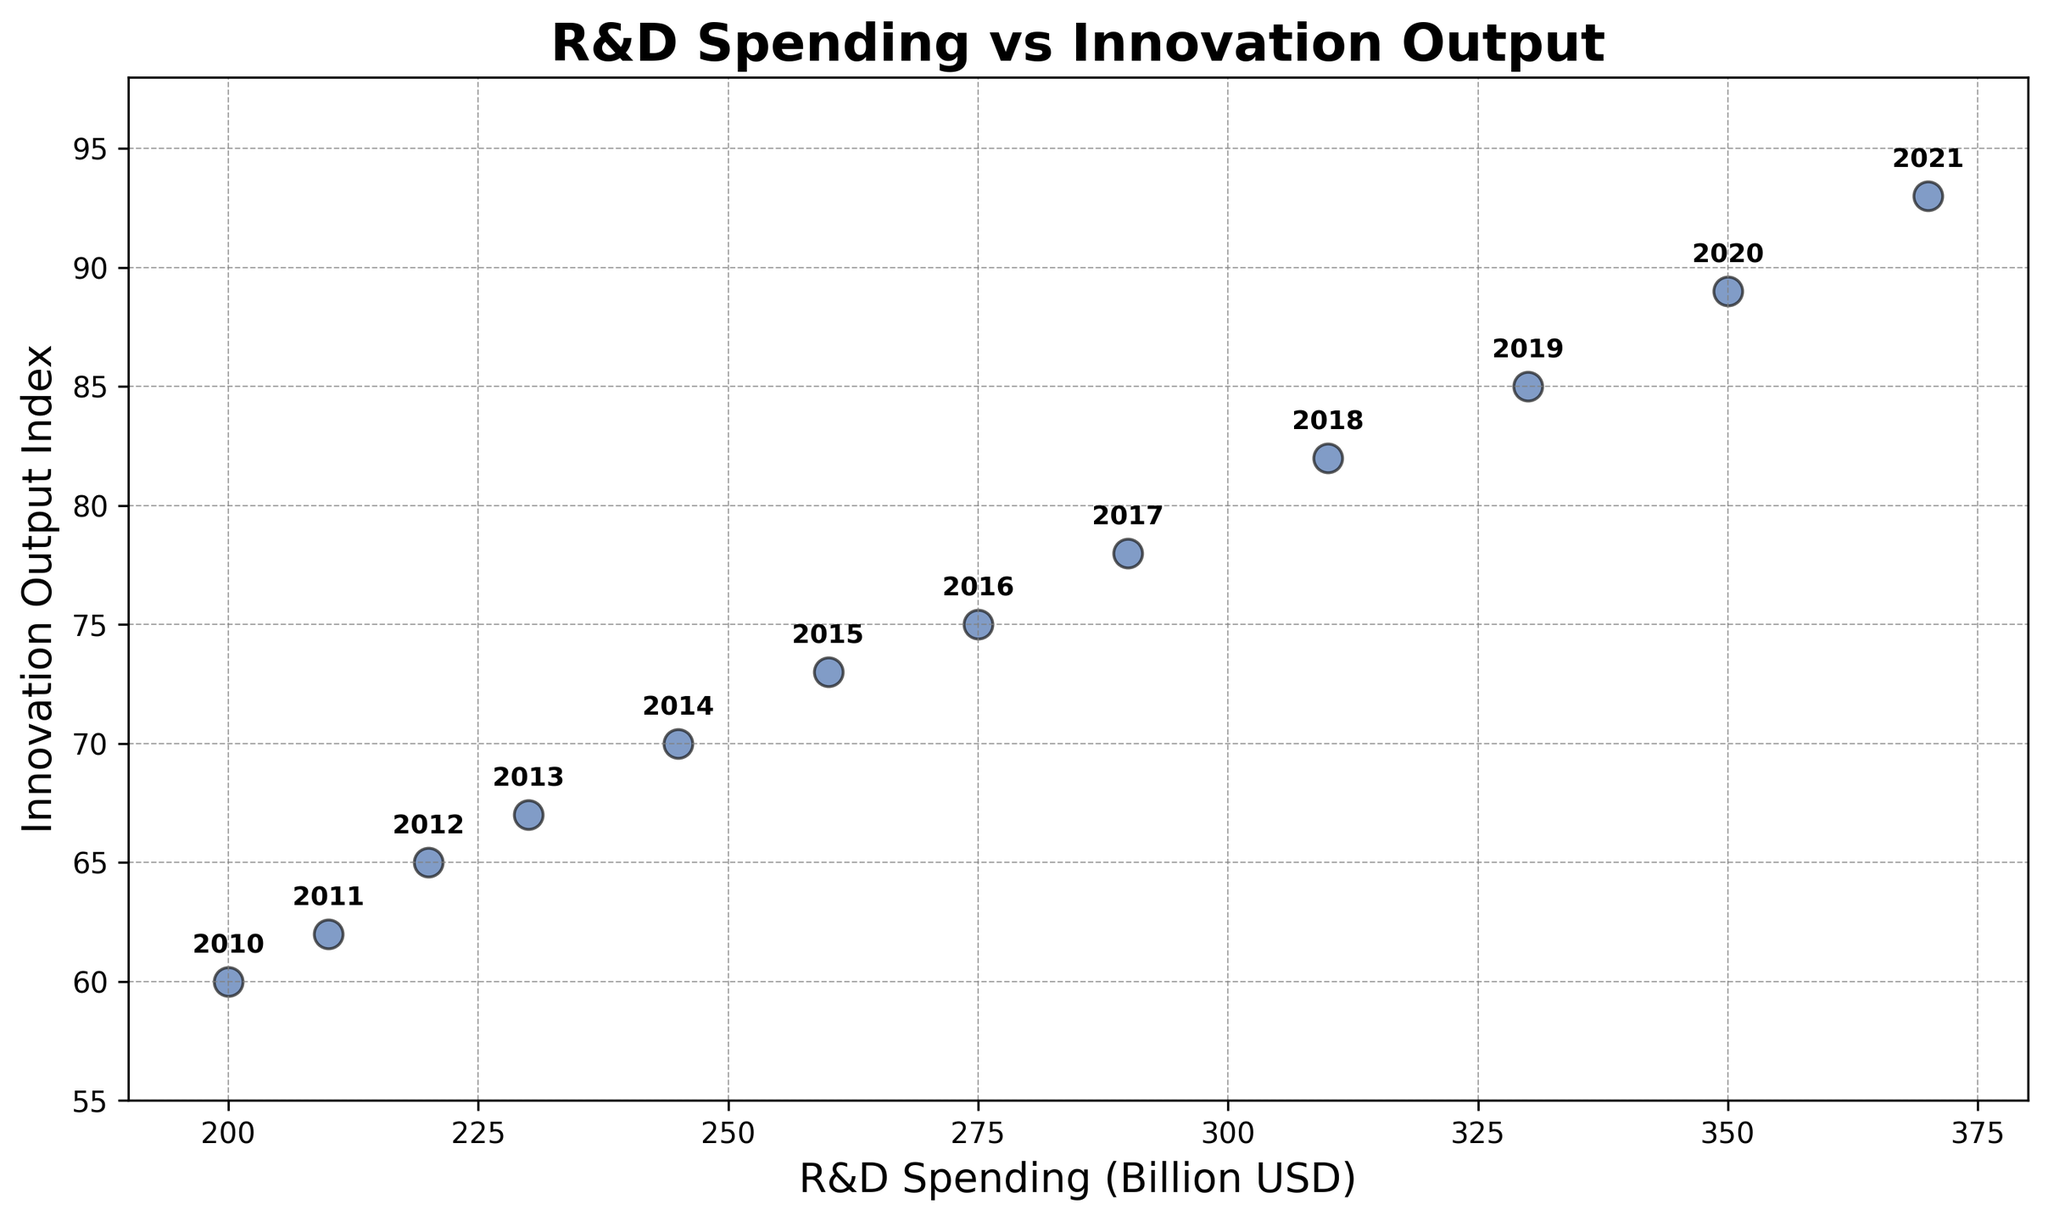How has the Innovation Output Index changed from 2010 to 2021? Compare the y-axis values for the years 2010 and 2021. In 2010, the Innovation Output Index is 60 and in 2021 it is 93. The difference is 93 - 60 = 33, showing an increase.
Answer: It has increased by 33 Which year saw the largest single-year increase in R&D Spending? Check the x-axis values for each consecutive year and calculate the differences. The largest increase is from 2019 to 2020, with an increase of 350 - 330 = 20 billion USD.
Answer: 2019 to 2020 Is the relationship between R&D Spending and Innovation Output mostly linear? Observe the scatter plot points; they roughly form a straight line suggesting a linear relationship.
Answer: Yes How much more was spent on R&D in 2021 compared to 2015? Compare the R&D Spending values for 2021 and 2015 on the x-axis. In 2021, it is 370 billion USD, and in 2015, it is 260 billion USD. The difference is 370 - 260 = 110 billion USD.
Answer: 110 billion USD Which year has the highest Innovation Output Index, and what is the corresponding R&D Spending? Identify the highest y-axis value. In 2021, the Innovation Output Index is 93, corresponding to an R&D Spending of 370 billion USD.
Answer: 2021 with 370 billion USD What is the average Innovation Output Index over the last decade? Sum up the Innovation Output Index values from 2012 to 2021 (65 + 67 + 70 + 73 + 75 + 78 + 82 + 85 + 89 + 93) = 767. Divide this by 10. The average is 76.7.
Answer: 76.7 Has there been any year where R&D Spending remained constant compared to the previous year? Check x-axis values for consecutive years. There are no cases where R&D Spending remains constant.
Answer: No Which year saw the smallest single-year increase in Innovation Output Index? Calculate the differences between consecutive y-axis values. The smallest increase is from 2011 to 2012, with an increase of 65 - 62 = 3.
Answer: 2011 to 2012 What is the total increase in R&D Spending over the entire period? Calculate the difference between the R&D Spending in 2021 and 2010 on the x-axis. The increase is 370 - 200 = 170 billion USD.
Answer: 170 billion USD How many years saw an increase in Innovation Output Index greater than 3? Calculate the year-over-year increases. Years with increases greater than 3 are 2011-2012 (3), 2014-2015 (3), 2016-2017 (3), and 2017-2018 (4). There are 4 such years.
Answer: 4 